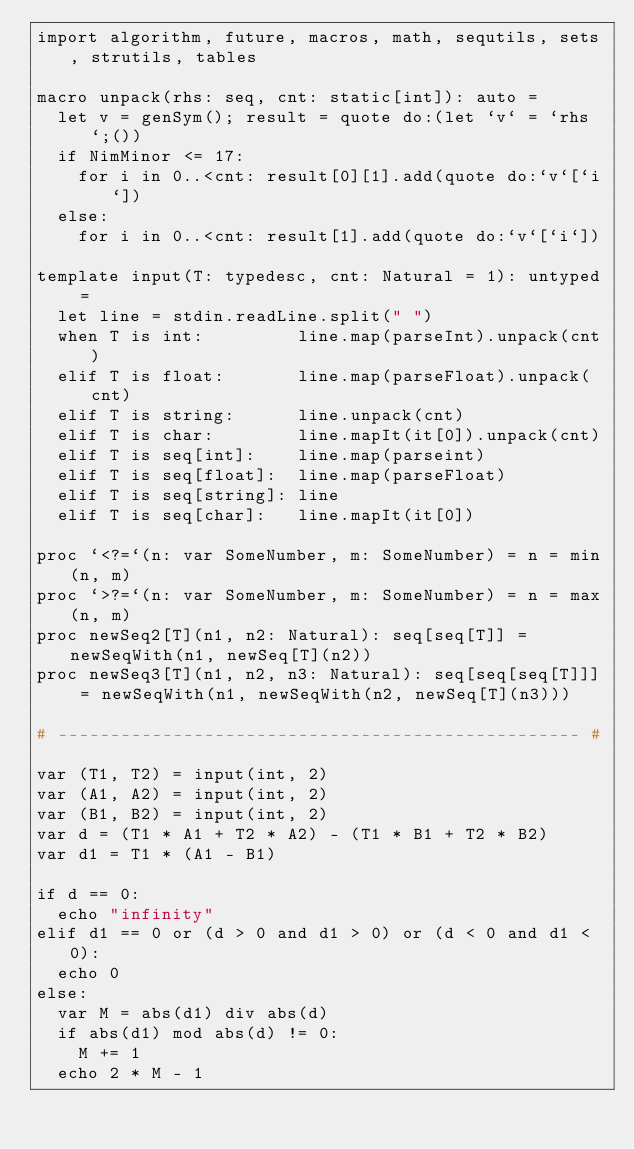Convert code to text. <code><loc_0><loc_0><loc_500><loc_500><_Nim_>import algorithm, future, macros, math, sequtils, sets, strutils, tables

macro unpack(rhs: seq, cnt: static[int]): auto =
  let v = genSym(); result = quote do:(let `v` = `rhs`;())
  if NimMinor <= 17:
    for i in 0..<cnt: result[0][1].add(quote do:`v`[`i`])
  else:
    for i in 0..<cnt: result[1].add(quote do:`v`[`i`])

template input(T: typedesc, cnt: Natural = 1): untyped =
  let line = stdin.readLine.split(" ")
  when T is int:         line.map(parseInt).unpack(cnt)
  elif T is float:       line.map(parseFloat).unpack(cnt)
  elif T is string:      line.unpack(cnt)
  elif T is char:        line.mapIt(it[0]).unpack(cnt)
  elif T is seq[int]:    line.map(parseint)
  elif T is seq[float]:  line.map(parseFloat)
  elif T is seq[string]: line
  elif T is seq[char]:   line.mapIt(it[0])

proc `<?=`(n: var SomeNumber, m: SomeNumber) = n = min(n, m)
proc `>?=`(n: var SomeNumber, m: SomeNumber) = n = max(n, m)
proc newSeq2[T](n1, n2: Natural): seq[seq[T]] = newSeqWith(n1, newSeq[T](n2))
proc newSeq3[T](n1, n2, n3: Natural): seq[seq[seq[T]]] = newSeqWith(n1, newSeqWith(n2, newSeq[T](n3)))

# -------------------------------------------------- #

var (T1, T2) = input(int, 2)
var (A1, A2) = input(int, 2)
var (B1, B2) = input(int, 2)
var d = (T1 * A1 + T2 * A2) - (T1 * B1 + T2 * B2)
var d1 = T1 * (A1 - B1)

if d == 0:
  echo "infinity"
elif d1 == 0 or (d > 0 and d1 > 0) or (d < 0 and d1 < 0):
  echo 0
else:
  var M = abs(d1) div abs(d)
  if abs(d1) mod abs(d) != 0:
    M += 1
  echo 2 * M - 1</code> 